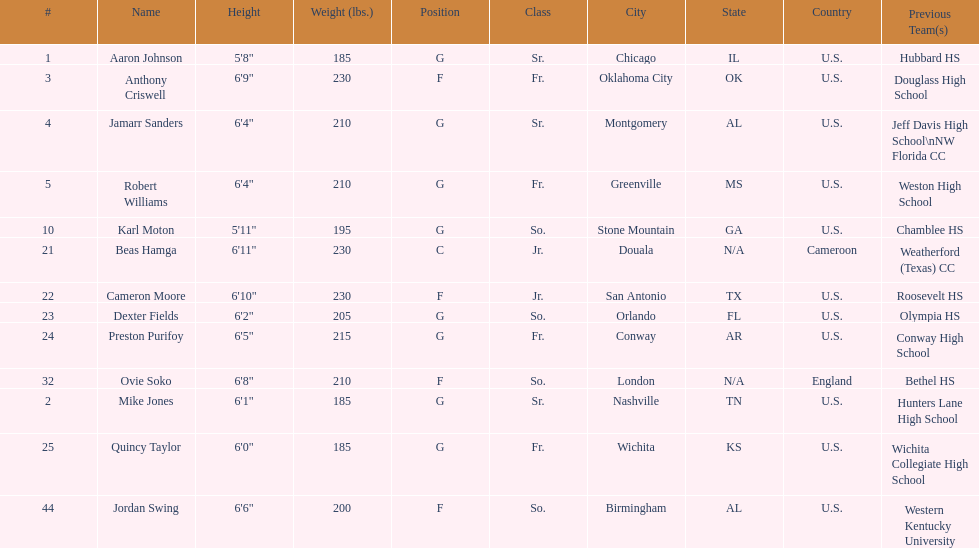Who are all the players? Aaron Johnson, Anthony Criswell, Jamarr Sanders, Robert Williams, Karl Moton, Beas Hamga, Cameron Moore, Dexter Fields, Preston Purifoy, Ovie Soko, Mike Jones, Quincy Taylor, Jordan Swing. Of these, which are not soko? Aaron Johnson, Anthony Criswell, Jamarr Sanders, Robert Williams, Karl Moton, Beas Hamga, Cameron Moore, Dexter Fields, Preston Purifoy, Mike Jones, Quincy Taylor, Jordan Swing. Where are these players from? Sr., Fr., Sr., Fr., So., Jr., Jr., So., Fr., Sr., Fr., So. Of these locations, which are not in the u.s.? Jr. Which player is from this location? Beas Hamga. 